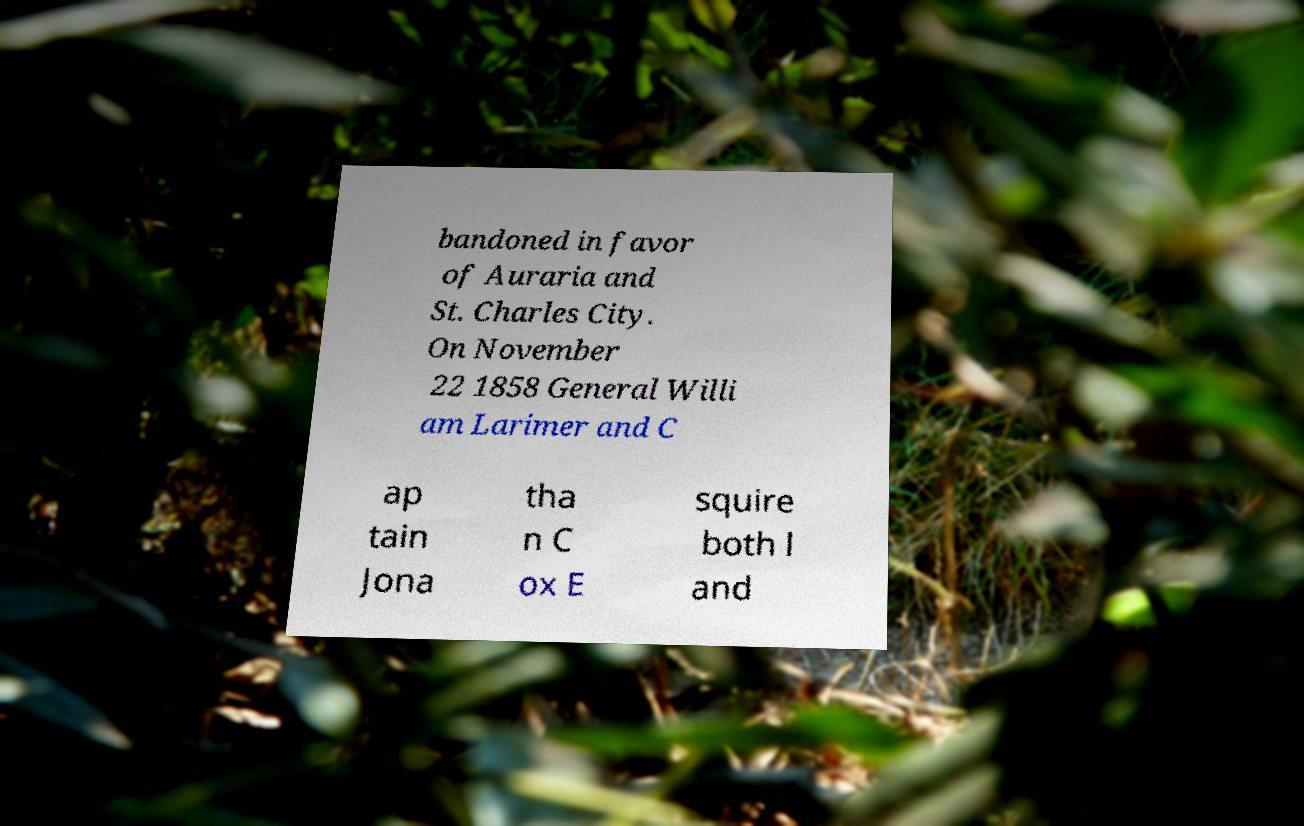I need the written content from this picture converted into text. Can you do that? bandoned in favor of Auraria and St. Charles City. On November 22 1858 General Willi am Larimer and C ap tain Jona tha n C ox E squire both l and 